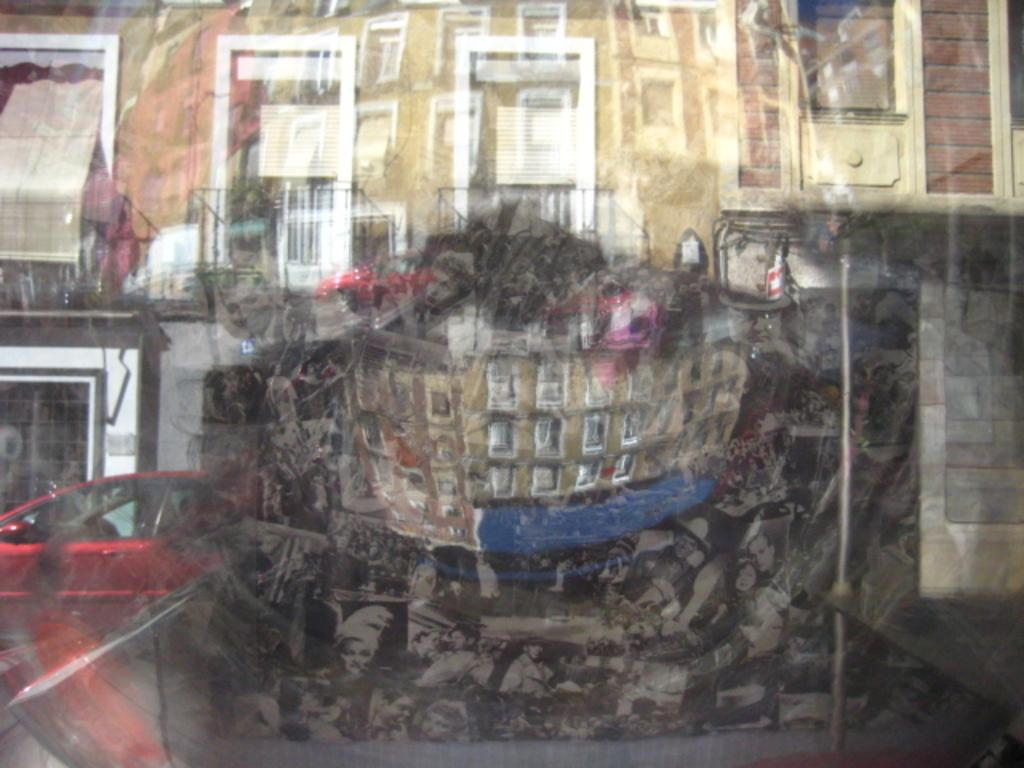What type of structure can be seen through the glass window in the image? A house building is visible through the window. What feature of the house building can be observed? The house building has windows. What is parked near the house building? There is a red car parked near the house building. What type of fork can be seen on the floor in the image? There is no fork present in the image; it only features a glass window, a house building, its windows, and a red car. 